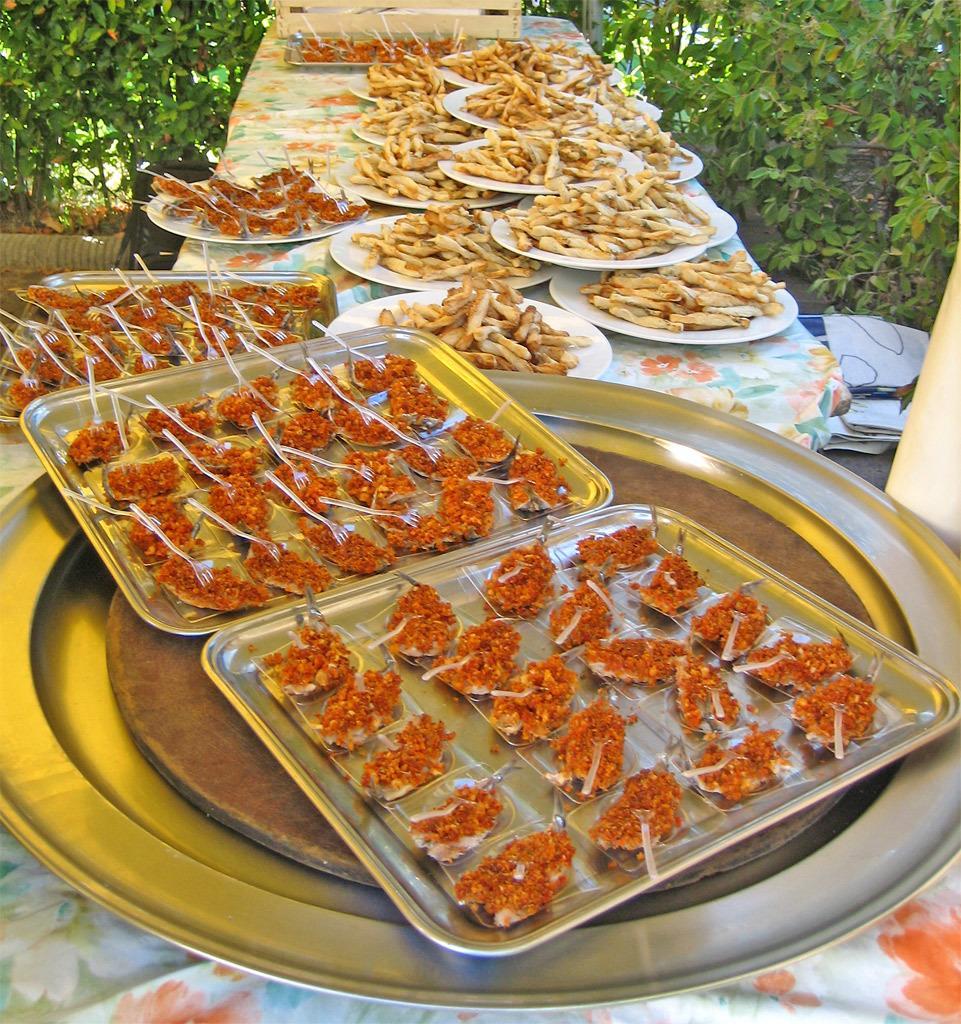Please provide a concise description of this image. In this image there are food items in the plates which was placed on the table. In the background of the image there are plants. 